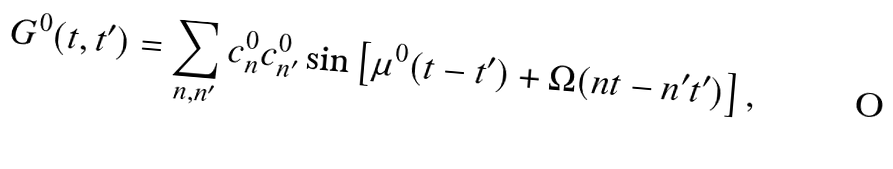Convert formula to latex. <formula><loc_0><loc_0><loc_500><loc_500>G ^ { 0 } ( t , t ^ { \prime } ) = \sum _ { n , n ^ { \prime } } c _ { n } ^ { 0 } c _ { n ^ { \prime } } ^ { 0 } \sin \left [ \mu ^ { 0 } ( t - t ^ { \prime } ) + \Omega ( n t - n ^ { \prime } t ^ { \prime } ) \right ] ,</formula> 